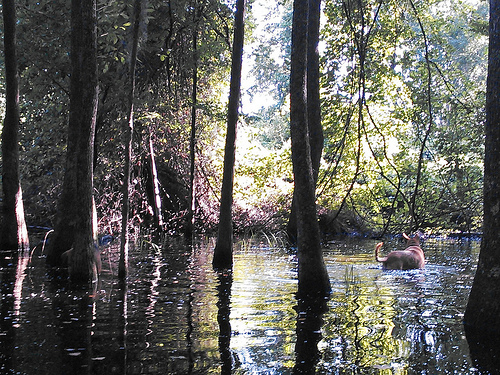<image>
Can you confirm if the dog is behind the tree? Yes. From this viewpoint, the dog is positioned behind the tree, with the tree partially or fully occluding the dog. 